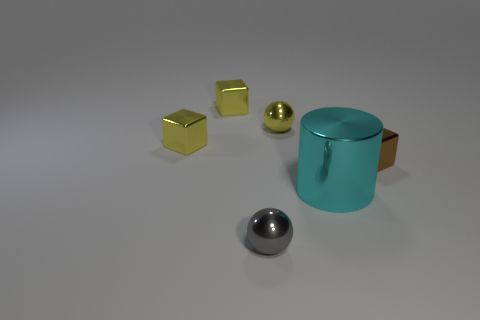Add 3 yellow blocks. How many objects exist? 9 Subtract all balls. How many objects are left? 4 Subtract all large cyan objects. Subtract all brown objects. How many objects are left? 4 Add 6 large shiny cylinders. How many large shiny cylinders are left? 7 Add 2 brown cubes. How many brown cubes exist? 3 Subtract 0 blue cylinders. How many objects are left? 6 